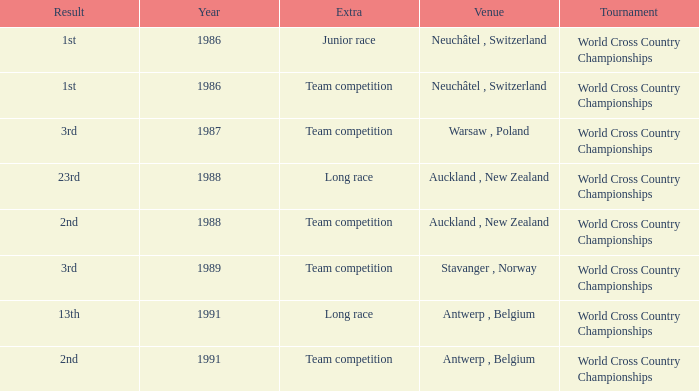Which venue led to a result of 13th and had an extra of Long Race? Antwerp , Belgium. 